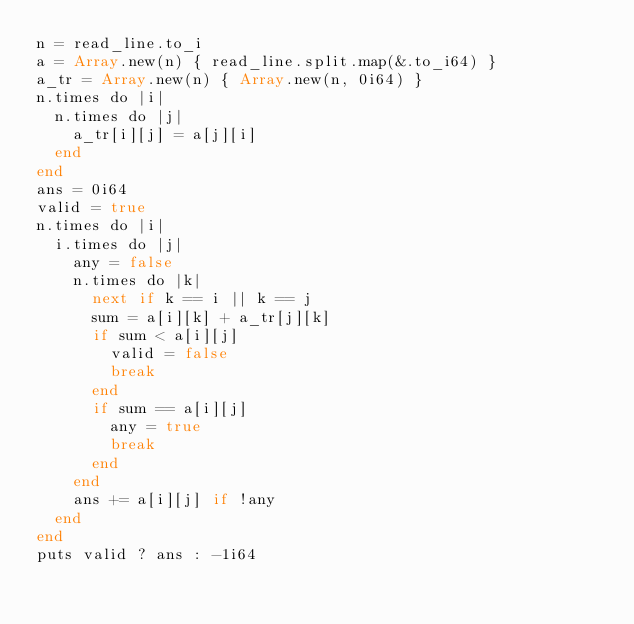<code> <loc_0><loc_0><loc_500><loc_500><_Crystal_>n = read_line.to_i
a = Array.new(n) { read_line.split.map(&.to_i64) }
a_tr = Array.new(n) { Array.new(n, 0i64) }
n.times do |i|
  n.times do |j|
    a_tr[i][j] = a[j][i]
  end
end
ans = 0i64
valid = true
n.times do |i|
  i.times do |j|
    any = false
    n.times do |k|
      next if k == i || k == j
      sum = a[i][k] + a_tr[j][k]
      if sum < a[i][j]
        valid = false
        break
      end
      if sum == a[i][j]
        any = true
        break
      end
    end
    ans += a[i][j] if !any
  end
end
puts valid ? ans : -1i64
</code> 